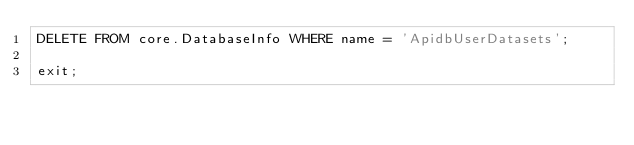<code> <loc_0><loc_0><loc_500><loc_500><_SQL_>DELETE FROM core.DatabaseInfo WHERE name = 'ApidbUserDatasets';

exit;
</code> 